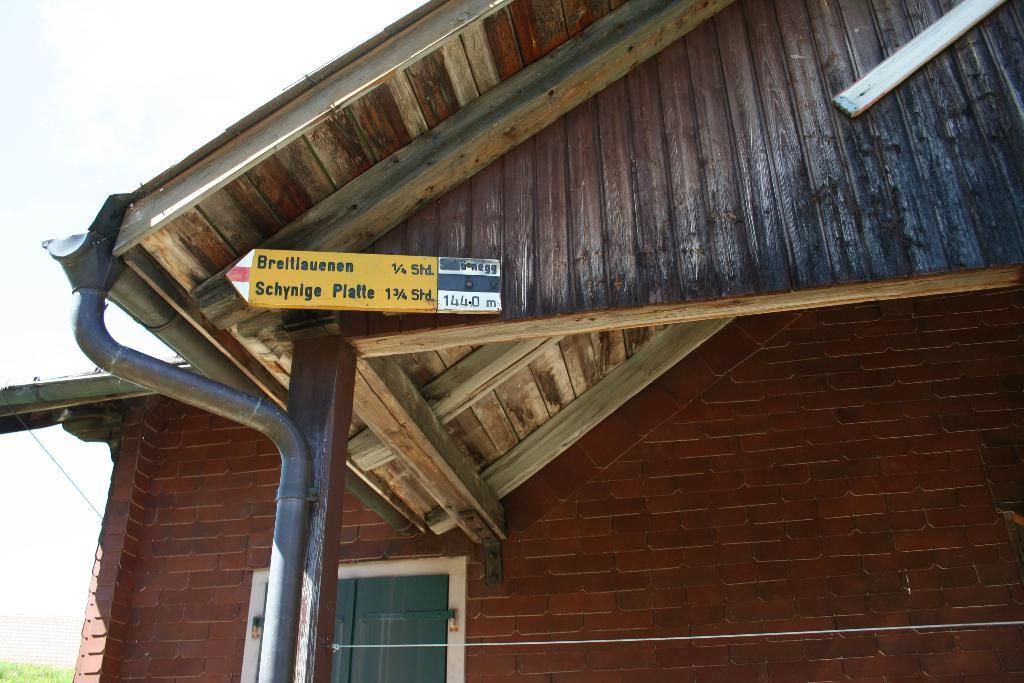What type of structure is present in the image? There is a house in the image. What other object can be seen in the image besides the house? There is a sign board in the image. What type of infrastructure is visible in the image? There are pipes and a cable visible in the image. What type of story is being told by the goat in the middle of the image? There is no goat present in the image, so it is not possible to answer that question. 